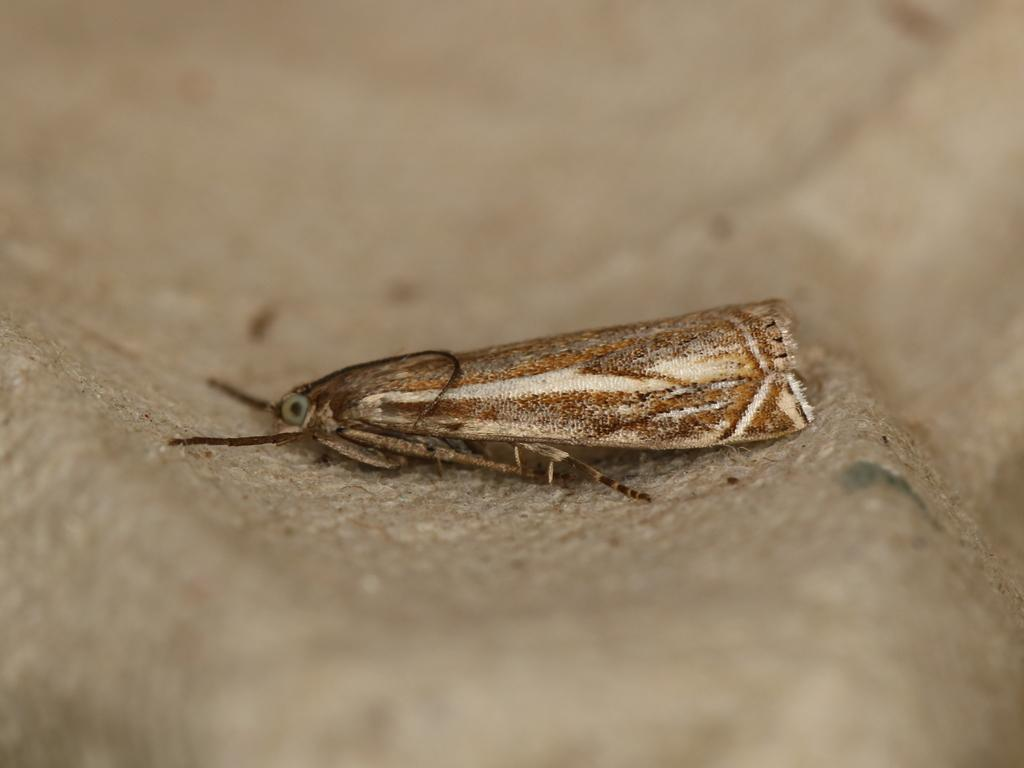What type of creature can be seen in the image? There is an insect in the image. What type of learning experience does the insect have in the image? There is no indication in the image that the insect is engaged in any learning experience. 